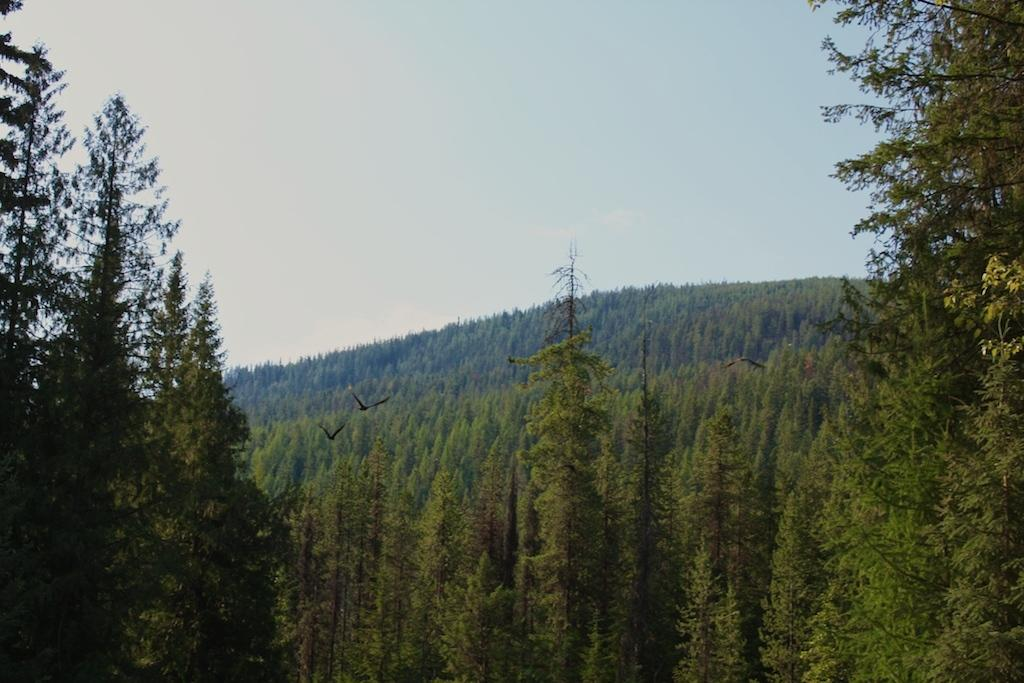What is happening in the image involving animals? There are birds flying in the image. What type of vegetation can be seen in the image? There are trees in the image. What part of the natural environment is visible in the image? The sky is visible in the image. Where is the shop located in the image? There is no shop present in the image. What discovery was made by the birds in the image? There is no indication of a discovery made by the birds in the image. 